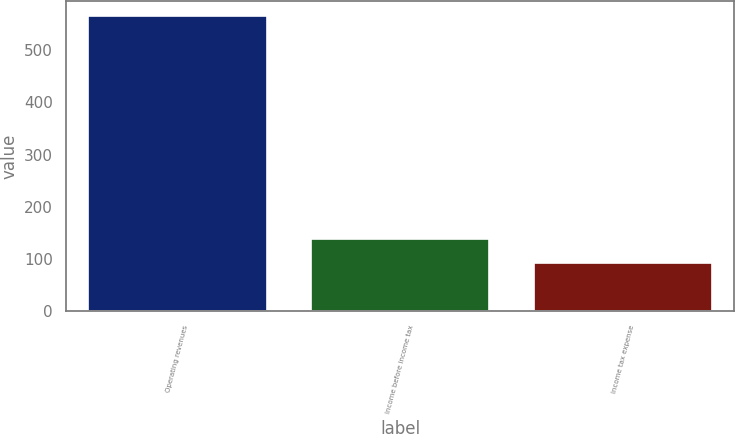Convert chart to OTSL. <chart><loc_0><loc_0><loc_500><loc_500><bar_chart><fcel>Operating revenues<fcel>Income before income tax<fcel>Income tax expense<nl><fcel>565<fcel>139.3<fcel>92<nl></chart> 